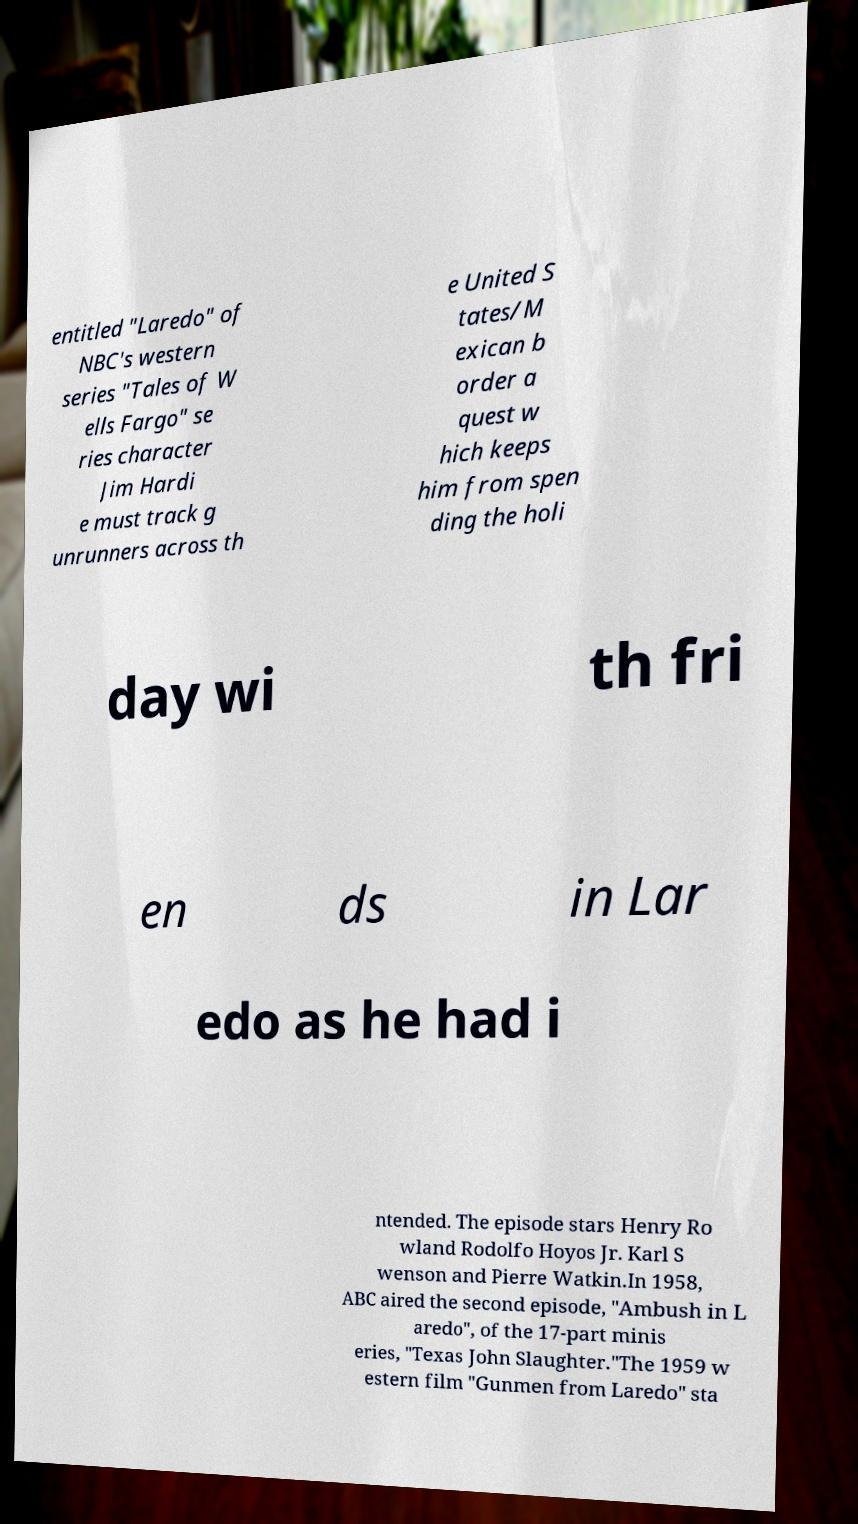There's text embedded in this image that I need extracted. Can you transcribe it verbatim? entitled "Laredo" of NBC's western series "Tales of W ells Fargo" se ries character Jim Hardi e must track g unrunners across th e United S tates/M exican b order a quest w hich keeps him from spen ding the holi day wi th fri en ds in Lar edo as he had i ntended. The episode stars Henry Ro wland Rodolfo Hoyos Jr. Karl S wenson and Pierre Watkin.In 1958, ABC aired the second episode, "Ambush in L aredo", of the 17-part minis eries, "Texas John Slaughter."The 1959 w estern film "Gunmen from Laredo" sta 